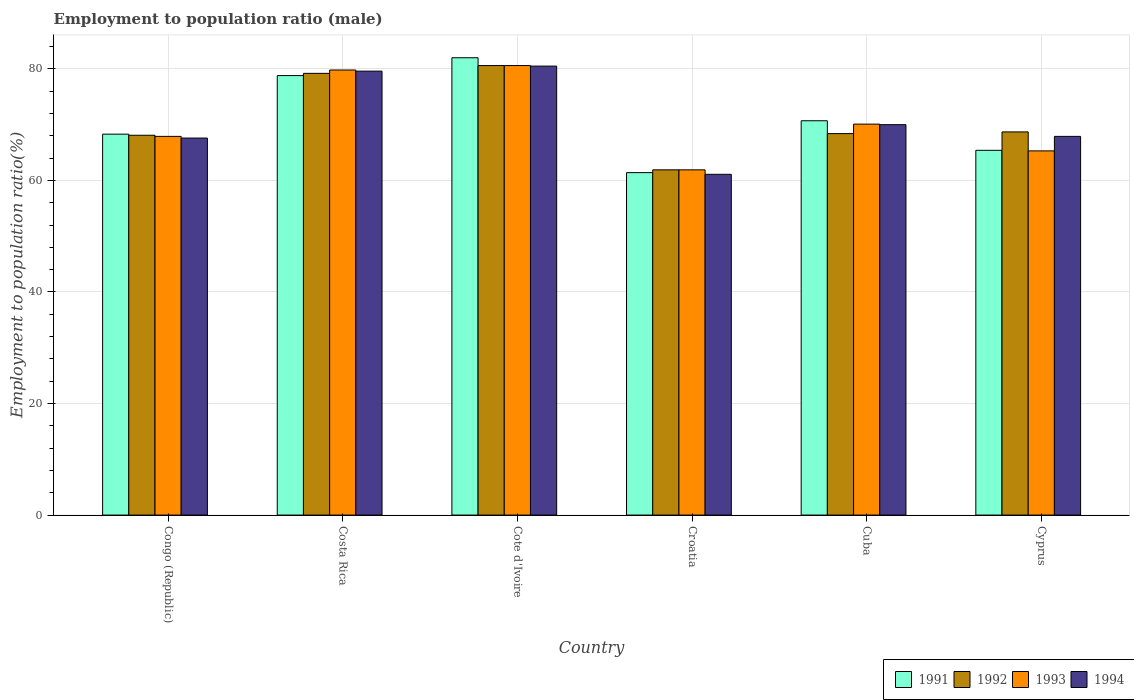How many bars are there on the 2nd tick from the right?
Give a very brief answer. 4. What is the label of the 3rd group of bars from the left?
Make the answer very short. Cote d'Ivoire. Across all countries, what is the minimum employment to population ratio in 1991?
Offer a very short reply. 61.4. In which country was the employment to population ratio in 1993 maximum?
Provide a succinct answer. Cote d'Ivoire. In which country was the employment to population ratio in 1993 minimum?
Provide a short and direct response. Croatia. What is the total employment to population ratio in 1991 in the graph?
Your response must be concise. 426.6. What is the difference between the employment to population ratio in 1994 in Cuba and that in Cyprus?
Give a very brief answer. 2.1. What is the difference between the employment to population ratio in 1994 in Cyprus and the employment to population ratio in 1992 in Cuba?
Give a very brief answer. -0.5. What is the average employment to population ratio in 1994 per country?
Ensure brevity in your answer.  71.12. What is the difference between the employment to population ratio of/in 1994 and employment to population ratio of/in 1991 in Costa Rica?
Offer a terse response. 0.8. What is the ratio of the employment to population ratio in 1991 in Costa Rica to that in Cote d'Ivoire?
Keep it short and to the point. 0.96. Is the employment to population ratio in 1992 in Congo (Republic) less than that in Cuba?
Your answer should be compact. Yes. What is the difference between the highest and the second highest employment to population ratio in 1992?
Provide a succinct answer. 11.9. What is the difference between the highest and the lowest employment to population ratio in 1992?
Offer a very short reply. 18.7. In how many countries, is the employment to population ratio in 1994 greater than the average employment to population ratio in 1994 taken over all countries?
Make the answer very short. 2. Are the values on the major ticks of Y-axis written in scientific E-notation?
Give a very brief answer. No. Does the graph contain any zero values?
Your answer should be very brief. No. Does the graph contain grids?
Provide a short and direct response. Yes. Where does the legend appear in the graph?
Provide a succinct answer. Bottom right. What is the title of the graph?
Your answer should be very brief. Employment to population ratio (male). What is the Employment to population ratio(%) in 1991 in Congo (Republic)?
Make the answer very short. 68.3. What is the Employment to population ratio(%) in 1992 in Congo (Republic)?
Give a very brief answer. 68.1. What is the Employment to population ratio(%) in 1993 in Congo (Republic)?
Your answer should be very brief. 67.9. What is the Employment to population ratio(%) of 1994 in Congo (Republic)?
Keep it short and to the point. 67.6. What is the Employment to population ratio(%) of 1991 in Costa Rica?
Offer a very short reply. 78.8. What is the Employment to population ratio(%) in 1992 in Costa Rica?
Provide a short and direct response. 79.2. What is the Employment to population ratio(%) in 1993 in Costa Rica?
Your response must be concise. 79.8. What is the Employment to population ratio(%) of 1994 in Costa Rica?
Ensure brevity in your answer.  79.6. What is the Employment to population ratio(%) in 1992 in Cote d'Ivoire?
Give a very brief answer. 80.6. What is the Employment to population ratio(%) of 1993 in Cote d'Ivoire?
Keep it short and to the point. 80.6. What is the Employment to population ratio(%) of 1994 in Cote d'Ivoire?
Provide a short and direct response. 80.5. What is the Employment to population ratio(%) in 1991 in Croatia?
Offer a very short reply. 61.4. What is the Employment to population ratio(%) in 1992 in Croatia?
Your answer should be compact. 61.9. What is the Employment to population ratio(%) in 1993 in Croatia?
Your answer should be very brief. 61.9. What is the Employment to population ratio(%) in 1994 in Croatia?
Ensure brevity in your answer.  61.1. What is the Employment to population ratio(%) in 1991 in Cuba?
Your answer should be compact. 70.7. What is the Employment to population ratio(%) of 1992 in Cuba?
Offer a terse response. 68.4. What is the Employment to population ratio(%) of 1993 in Cuba?
Offer a very short reply. 70.1. What is the Employment to population ratio(%) in 1991 in Cyprus?
Offer a very short reply. 65.4. What is the Employment to population ratio(%) in 1992 in Cyprus?
Keep it short and to the point. 68.7. What is the Employment to population ratio(%) in 1993 in Cyprus?
Make the answer very short. 65.3. What is the Employment to population ratio(%) of 1994 in Cyprus?
Your answer should be very brief. 67.9. Across all countries, what is the maximum Employment to population ratio(%) in 1992?
Provide a short and direct response. 80.6. Across all countries, what is the maximum Employment to population ratio(%) in 1993?
Make the answer very short. 80.6. Across all countries, what is the maximum Employment to population ratio(%) in 1994?
Your answer should be very brief. 80.5. Across all countries, what is the minimum Employment to population ratio(%) of 1991?
Offer a very short reply. 61.4. Across all countries, what is the minimum Employment to population ratio(%) in 1992?
Your response must be concise. 61.9. Across all countries, what is the minimum Employment to population ratio(%) in 1993?
Offer a terse response. 61.9. Across all countries, what is the minimum Employment to population ratio(%) in 1994?
Offer a terse response. 61.1. What is the total Employment to population ratio(%) in 1991 in the graph?
Give a very brief answer. 426.6. What is the total Employment to population ratio(%) in 1992 in the graph?
Your answer should be very brief. 426.9. What is the total Employment to population ratio(%) of 1993 in the graph?
Provide a succinct answer. 425.6. What is the total Employment to population ratio(%) of 1994 in the graph?
Offer a very short reply. 426.7. What is the difference between the Employment to population ratio(%) in 1991 in Congo (Republic) and that in Costa Rica?
Give a very brief answer. -10.5. What is the difference between the Employment to population ratio(%) of 1993 in Congo (Republic) and that in Costa Rica?
Make the answer very short. -11.9. What is the difference between the Employment to population ratio(%) in 1991 in Congo (Republic) and that in Cote d'Ivoire?
Give a very brief answer. -13.7. What is the difference between the Employment to population ratio(%) in 1992 in Congo (Republic) and that in Cote d'Ivoire?
Your response must be concise. -12.5. What is the difference between the Employment to population ratio(%) of 1993 in Congo (Republic) and that in Cote d'Ivoire?
Make the answer very short. -12.7. What is the difference between the Employment to population ratio(%) in 1994 in Congo (Republic) and that in Cote d'Ivoire?
Give a very brief answer. -12.9. What is the difference between the Employment to population ratio(%) in 1991 in Congo (Republic) and that in Croatia?
Your response must be concise. 6.9. What is the difference between the Employment to population ratio(%) in 1992 in Congo (Republic) and that in Croatia?
Provide a short and direct response. 6.2. What is the difference between the Employment to population ratio(%) in 1994 in Congo (Republic) and that in Croatia?
Give a very brief answer. 6.5. What is the difference between the Employment to population ratio(%) of 1991 in Congo (Republic) and that in Cuba?
Offer a terse response. -2.4. What is the difference between the Employment to population ratio(%) of 1992 in Congo (Republic) and that in Cuba?
Your answer should be very brief. -0.3. What is the difference between the Employment to population ratio(%) in 1994 in Congo (Republic) and that in Cuba?
Your response must be concise. -2.4. What is the difference between the Employment to population ratio(%) in 1993 in Congo (Republic) and that in Cyprus?
Provide a short and direct response. 2.6. What is the difference between the Employment to population ratio(%) of 1993 in Costa Rica and that in Cote d'Ivoire?
Offer a very short reply. -0.8. What is the difference between the Employment to population ratio(%) of 1994 in Costa Rica and that in Cote d'Ivoire?
Ensure brevity in your answer.  -0.9. What is the difference between the Employment to population ratio(%) of 1992 in Costa Rica and that in Croatia?
Your answer should be compact. 17.3. What is the difference between the Employment to population ratio(%) in 1991 in Costa Rica and that in Cuba?
Provide a short and direct response. 8.1. What is the difference between the Employment to population ratio(%) of 1992 in Costa Rica and that in Cuba?
Your answer should be compact. 10.8. What is the difference between the Employment to population ratio(%) in 1993 in Costa Rica and that in Cuba?
Your response must be concise. 9.7. What is the difference between the Employment to population ratio(%) in 1992 in Costa Rica and that in Cyprus?
Give a very brief answer. 10.5. What is the difference between the Employment to population ratio(%) of 1994 in Costa Rica and that in Cyprus?
Give a very brief answer. 11.7. What is the difference between the Employment to population ratio(%) in 1991 in Cote d'Ivoire and that in Croatia?
Offer a terse response. 20.6. What is the difference between the Employment to population ratio(%) in 1992 in Cote d'Ivoire and that in Croatia?
Provide a short and direct response. 18.7. What is the difference between the Employment to population ratio(%) of 1994 in Cote d'Ivoire and that in Croatia?
Make the answer very short. 19.4. What is the difference between the Employment to population ratio(%) in 1994 in Cote d'Ivoire and that in Cuba?
Provide a succinct answer. 10.5. What is the difference between the Employment to population ratio(%) in 1992 in Cote d'Ivoire and that in Cyprus?
Your answer should be compact. 11.9. What is the difference between the Employment to population ratio(%) in 1992 in Croatia and that in Cuba?
Your answer should be compact. -6.5. What is the difference between the Employment to population ratio(%) in 1993 in Croatia and that in Cyprus?
Your answer should be very brief. -3.4. What is the difference between the Employment to population ratio(%) of 1994 in Croatia and that in Cyprus?
Your answer should be very brief. -6.8. What is the difference between the Employment to population ratio(%) of 1991 in Congo (Republic) and the Employment to population ratio(%) of 1993 in Costa Rica?
Your answer should be compact. -11.5. What is the difference between the Employment to population ratio(%) of 1992 in Congo (Republic) and the Employment to population ratio(%) of 1993 in Costa Rica?
Your response must be concise. -11.7. What is the difference between the Employment to population ratio(%) in 1991 in Congo (Republic) and the Employment to population ratio(%) in 1992 in Cote d'Ivoire?
Provide a succinct answer. -12.3. What is the difference between the Employment to population ratio(%) in 1991 in Congo (Republic) and the Employment to population ratio(%) in 1993 in Cote d'Ivoire?
Make the answer very short. -12.3. What is the difference between the Employment to population ratio(%) of 1991 in Congo (Republic) and the Employment to population ratio(%) of 1994 in Cote d'Ivoire?
Keep it short and to the point. -12.2. What is the difference between the Employment to population ratio(%) of 1992 in Congo (Republic) and the Employment to population ratio(%) of 1993 in Cote d'Ivoire?
Provide a succinct answer. -12.5. What is the difference between the Employment to population ratio(%) in 1992 in Congo (Republic) and the Employment to population ratio(%) in 1994 in Cote d'Ivoire?
Offer a very short reply. -12.4. What is the difference between the Employment to population ratio(%) in 1991 in Congo (Republic) and the Employment to population ratio(%) in 1993 in Croatia?
Your response must be concise. 6.4. What is the difference between the Employment to population ratio(%) in 1991 in Congo (Republic) and the Employment to population ratio(%) in 1994 in Croatia?
Offer a very short reply. 7.2. What is the difference between the Employment to population ratio(%) of 1992 in Congo (Republic) and the Employment to population ratio(%) of 1994 in Croatia?
Your answer should be compact. 7. What is the difference between the Employment to population ratio(%) of 1993 in Congo (Republic) and the Employment to population ratio(%) of 1994 in Croatia?
Keep it short and to the point. 6.8. What is the difference between the Employment to population ratio(%) in 1991 in Congo (Republic) and the Employment to population ratio(%) in 1992 in Cuba?
Keep it short and to the point. -0.1. What is the difference between the Employment to population ratio(%) in 1991 in Congo (Republic) and the Employment to population ratio(%) in 1994 in Cuba?
Give a very brief answer. -1.7. What is the difference between the Employment to population ratio(%) in 1992 in Congo (Republic) and the Employment to population ratio(%) in 1993 in Cuba?
Your response must be concise. -2. What is the difference between the Employment to population ratio(%) in 1992 in Congo (Republic) and the Employment to population ratio(%) in 1994 in Cuba?
Your answer should be compact. -1.9. What is the difference between the Employment to population ratio(%) of 1991 in Congo (Republic) and the Employment to population ratio(%) of 1994 in Cyprus?
Your answer should be very brief. 0.4. What is the difference between the Employment to population ratio(%) of 1992 in Congo (Republic) and the Employment to population ratio(%) of 1993 in Cyprus?
Your answer should be very brief. 2.8. What is the difference between the Employment to population ratio(%) in 1991 in Costa Rica and the Employment to population ratio(%) in 1993 in Cote d'Ivoire?
Your answer should be compact. -1.8. What is the difference between the Employment to population ratio(%) in 1992 in Costa Rica and the Employment to population ratio(%) in 1994 in Cote d'Ivoire?
Your answer should be compact. -1.3. What is the difference between the Employment to population ratio(%) in 1991 in Costa Rica and the Employment to population ratio(%) in 1992 in Croatia?
Offer a terse response. 16.9. What is the difference between the Employment to population ratio(%) of 1991 in Costa Rica and the Employment to population ratio(%) of 1993 in Croatia?
Your response must be concise. 16.9. What is the difference between the Employment to population ratio(%) in 1992 in Costa Rica and the Employment to population ratio(%) in 1993 in Croatia?
Provide a short and direct response. 17.3. What is the difference between the Employment to population ratio(%) in 1992 in Costa Rica and the Employment to population ratio(%) in 1994 in Croatia?
Your response must be concise. 18.1. What is the difference between the Employment to population ratio(%) of 1993 in Costa Rica and the Employment to population ratio(%) of 1994 in Croatia?
Your answer should be very brief. 18.7. What is the difference between the Employment to population ratio(%) in 1992 in Costa Rica and the Employment to population ratio(%) in 1994 in Cuba?
Give a very brief answer. 9.2. What is the difference between the Employment to population ratio(%) in 1992 in Costa Rica and the Employment to population ratio(%) in 1993 in Cyprus?
Offer a very short reply. 13.9. What is the difference between the Employment to population ratio(%) in 1992 in Costa Rica and the Employment to population ratio(%) in 1994 in Cyprus?
Make the answer very short. 11.3. What is the difference between the Employment to population ratio(%) of 1991 in Cote d'Ivoire and the Employment to population ratio(%) of 1992 in Croatia?
Ensure brevity in your answer.  20.1. What is the difference between the Employment to population ratio(%) of 1991 in Cote d'Ivoire and the Employment to population ratio(%) of 1993 in Croatia?
Your response must be concise. 20.1. What is the difference between the Employment to population ratio(%) in 1991 in Cote d'Ivoire and the Employment to population ratio(%) in 1994 in Croatia?
Make the answer very short. 20.9. What is the difference between the Employment to population ratio(%) of 1991 in Cote d'Ivoire and the Employment to population ratio(%) of 1992 in Cuba?
Ensure brevity in your answer.  13.6. What is the difference between the Employment to population ratio(%) in 1993 in Cote d'Ivoire and the Employment to population ratio(%) in 1994 in Cuba?
Your response must be concise. 10.6. What is the difference between the Employment to population ratio(%) of 1991 in Cote d'Ivoire and the Employment to population ratio(%) of 1992 in Cyprus?
Provide a short and direct response. 13.3. What is the difference between the Employment to population ratio(%) in 1991 in Cote d'Ivoire and the Employment to population ratio(%) in 1994 in Cyprus?
Provide a short and direct response. 14.1. What is the difference between the Employment to population ratio(%) of 1992 in Cote d'Ivoire and the Employment to population ratio(%) of 1994 in Cyprus?
Your answer should be compact. 12.7. What is the difference between the Employment to population ratio(%) in 1993 in Cote d'Ivoire and the Employment to population ratio(%) in 1994 in Cyprus?
Provide a succinct answer. 12.7. What is the difference between the Employment to population ratio(%) of 1992 in Croatia and the Employment to population ratio(%) of 1994 in Cuba?
Provide a succinct answer. -8.1. What is the difference between the Employment to population ratio(%) of 1992 in Croatia and the Employment to population ratio(%) of 1994 in Cyprus?
Offer a very short reply. -6. What is the difference between the Employment to population ratio(%) in 1993 in Croatia and the Employment to population ratio(%) in 1994 in Cyprus?
Your answer should be very brief. -6. What is the difference between the Employment to population ratio(%) of 1992 in Cuba and the Employment to population ratio(%) of 1993 in Cyprus?
Your response must be concise. 3.1. What is the difference between the Employment to population ratio(%) in 1992 in Cuba and the Employment to population ratio(%) in 1994 in Cyprus?
Offer a very short reply. 0.5. What is the difference between the Employment to population ratio(%) of 1993 in Cuba and the Employment to population ratio(%) of 1994 in Cyprus?
Offer a very short reply. 2.2. What is the average Employment to population ratio(%) in 1991 per country?
Ensure brevity in your answer.  71.1. What is the average Employment to population ratio(%) of 1992 per country?
Keep it short and to the point. 71.15. What is the average Employment to population ratio(%) of 1993 per country?
Make the answer very short. 70.93. What is the average Employment to population ratio(%) of 1994 per country?
Offer a terse response. 71.12. What is the difference between the Employment to population ratio(%) of 1991 and Employment to population ratio(%) of 1993 in Congo (Republic)?
Ensure brevity in your answer.  0.4. What is the difference between the Employment to population ratio(%) in 1991 and Employment to population ratio(%) in 1994 in Congo (Republic)?
Offer a very short reply. 0.7. What is the difference between the Employment to population ratio(%) of 1992 and Employment to population ratio(%) of 1993 in Congo (Republic)?
Provide a succinct answer. 0.2. What is the difference between the Employment to population ratio(%) in 1991 and Employment to population ratio(%) in 1992 in Costa Rica?
Your response must be concise. -0.4. What is the difference between the Employment to population ratio(%) in 1991 and Employment to population ratio(%) in 1993 in Costa Rica?
Keep it short and to the point. -1. What is the difference between the Employment to population ratio(%) in 1992 and Employment to population ratio(%) in 1993 in Costa Rica?
Provide a short and direct response. -0.6. What is the difference between the Employment to population ratio(%) in 1992 and Employment to population ratio(%) in 1994 in Costa Rica?
Offer a terse response. -0.4. What is the difference between the Employment to population ratio(%) of 1993 and Employment to population ratio(%) of 1994 in Costa Rica?
Your answer should be very brief. 0.2. What is the difference between the Employment to population ratio(%) of 1991 and Employment to population ratio(%) of 1993 in Cote d'Ivoire?
Make the answer very short. 1.4. What is the difference between the Employment to population ratio(%) of 1992 and Employment to population ratio(%) of 1993 in Cote d'Ivoire?
Provide a short and direct response. 0. What is the difference between the Employment to population ratio(%) of 1993 and Employment to population ratio(%) of 1994 in Cote d'Ivoire?
Your answer should be very brief. 0.1. What is the difference between the Employment to population ratio(%) in 1991 and Employment to population ratio(%) in 1993 in Croatia?
Give a very brief answer. -0.5. What is the difference between the Employment to population ratio(%) of 1991 and Employment to population ratio(%) of 1994 in Croatia?
Provide a succinct answer. 0.3. What is the difference between the Employment to population ratio(%) in 1993 and Employment to population ratio(%) in 1994 in Croatia?
Your answer should be very brief. 0.8. What is the difference between the Employment to population ratio(%) of 1991 and Employment to population ratio(%) of 1992 in Cyprus?
Ensure brevity in your answer.  -3.3. What is the difference between the Employment to population ratio(%) in 1992 and Employment to population ratio(%) in 1994 in Cyprus?
Give a very brief answer. 0.8. What is the difference between the Employment to population ratio(%) of 1993 and Employment to population ratio(%) of 1994 in Cyprus?
Offer a terse response. -2.6. What is the ratio of the Employment to population ratio(%) of 1991 in Congo (Republic) to that in Costa Rica?
Your answer should be compact. 0.87. What is the ratio of the Employment to population ratio(%) of 1992 in Congo (Republic) to that in Costa Rica?
Your response must be concise. 0.86. What is the ratio of the Employment to population ratio(%) of 1993 in Congo (Republic) to that in Costa Rica?
Keep it short and to the point. 0.85. What is the ratio of the Employment to population ratio(%) of 1994 in Congo (Republic) to that in Costa Rica?
Offer a terse response. 0.85. What is the ratio of the Employment to population ratio(%) in 1991 in Congo (Republic) to that in Cote d'Ivoire?
Your answer should be very brief. 0.83. What is the ratio of the Employment to population ratio(%) in 1992 in Congo (Republic) to that in Cote d'Ivoire?
Make the answer very short. 0.84. What is the ratio of the Employment to population ratio(%) of 1993 in Congo (Republic) to that in Cote d'Ivoire?
Keep it short and to the point. 0.84. What is the ratio of the Employment to population ratio(%) of 1994 in Congo (Republic) to that in Cote d'Ivoire?
Provide a succinct answer. 0.84. What is the ratio of the Employment to population ratio(%) of 1991 in Congo (Republic) to that in Croatia?
Make the answer very short. 1.11. What is the ratio of the Employment to population ratio(%) of 1992 in Congo (Republic) to that in Croatia?
Your response must be concise. 1.1. What is the ratio of the Employment to population ratio(%) in 1993 in Congo (Republic) to that in Croatia?
Make the answer very short. 1.1. What is the ratio of the Employment to population ratio(%) of 1994 in Congo (Republic) to that in Croatia?
Your answer should be compact. 1.11. What is the ratio of the Employment to population ratio(%) of 1991 in Congo (Republic) to that in Cuba?
Offer a terse response. 0.97. What is the ratio of the Employment to population ratio(%) of 1992 in Congo (Republic) to that in Cuba?
Your response must be concise. 1. What is the ratio of the Employment to population ratio(%) in 1993 in Congo (Republic) to that in Cuba?
Your answer should be very brief. 0.97. What is the ratio of the Employment to population ratio(%) in 1994 in Congo (Republic) to that in Cuba?
Make the answer very short. 0.97. What is the ratio of the Employment to population ratio(%) of 1991 in Congo (Republic) to that in Cyprus?
Your answer should be very brief. 1.04. What is the ratio of the Employment to population ratio(%) of 1992 in Congo (Republic) to that in Cyprus?
Ensure brevity in your answer.  0.99. What is the ratio of the Employment to population ratio(%) in 1993 in Congo (Republic) to that in Cyprus?
Make the answer very short. 1.04. What is the ratio of the Employment to population ratio(%) in 1992 in Costa Rica to that in Cote d'Ivoire?
Keep it short and to the point. 0.98. What is the ratio of the Employment to population ratio(%) of 1993 in Costa Rica to that in Cote d'Ivoire?
Provide a short and direct response. 0.99. What is the ratio of the Employment to population ratio(%) of 1994 in Costa Rica to that in Cote d'Ivoire?
Provide a succinct answer. 0.99. What is the ratio of the Employment to population ratio(%) of 1991 in Costa Rica to that in Croatia?
Offer a very short reply. 1.28. What is the ratio of the Employment to population ratio(%) in 1992 in Costa Rica to that in Croatia?
Make the answer very short. 1.28. What is the ratio of the Employment to population ratio(%) of 1993 in Costa Rica to that in Croatia?
Your answer should be compact. 1.29. What is the ratio of the Employment to population ratio(%) of 1994 in Costa Rica to that in Croatia?
Your answer should be compact. 1.3. What is the ratio of the Employment to population ratio(%) of 1991 in Costa Rica to that in Cuba?
Keep it short and to the point. 1.11. What is the ratio of the Employment to population ratio(%) of 1992 in Costa Rica to that in Cuba?
Ensure brevity in your answer.  1.16. What is the ratio of the Employment to population ratio(%) in 1993 in Costa Rica to that in Cuba?
Give a very brief answer. 1.14. What is the ratio of the Employment to population ratio(%) of 1994 in Costa Rica to that in Cuba?
Provide a short and direct response. 1.14. What is the ratio of the Employment to population ratio(%) of 1991 in Costa Rica to that in Cyprus?
Keep it short and to the point. 1.2. What is the ratio of the Employment to population ratio(%) in 1992 in Costa Rica to that in Cyprus?
Offer a terse response. 1.15. What is the ratio of the Employment to population ratio(%) in 1993 in Costa Rica to that in Cyprus?
Make the answer very short. 1.22. What is the ratio of the Employment to population ratio(%) of 1994 in Costa Rica to that in Cyprus?
Offer a terse response. 1.17. What is the ratio of the Employment to population ratio(%) in 1991 in Cote d'Ivoire to that in Croatia?
Your answer should be very brief. 1.34. What is the ratio of the Employment to population ratio(%) in 1992 in Cote d'Ivoire to that in Croatia?
Give a very brief answer. 1.3. What is the ratio of the Employment to population ratio(%) of 1993 in Cote d'Ivoire to that in Croatia?
Your answer should be compact. 1.3. What is the ratio of the Employment to population ratio(%) of 1994 in Cote d'Ivoire to that in Croatia?
Provide a short and direct response. 1.32. What is the ratio of the Employment to population ratio(%) of 1991 in Cote d'Ivoire to that in Cuba?
Ensure brevity in your answer.  1.16. What is the ratio of the Employment to population ratio(%) in 1992 in Cote d'Ivoire to that in Cuba?
Make the answer very short. 1.18. What is the ratio of the Employment to population ratio(%) in 1993 in Cote d'Ivoire to that in Cuba?
Make the answer very short. 1.15. What is the ratio of the Employment to population ratio(%) in 1994 in Cote d'Ivoire to that in Cuba?
Make the answer very short. 1.15. What is the ratio of the Employment to population ratio(%) of 1991 in Cote d'Ivoire to that in Cyprus?
Keep it short and to the point. 1.25. What is the ratio of the Employment to population ratio(%) in 1992 in Cote d'Ivoire to that in Cyprus?
Ensure brevity in your answer.  1.17. What is the ratio of the Employment to population ratio(%) of 1993 in Cote d'Ivoire to that in Cyprus?
Your answer should be compact. 1.23. What is the ratio of the Employment to population ratio(%) of 1994 in Cote d'Ivoire to that in Cyprus?
Give a very brief answer. 1.19. What is the ratio of the Employment to population ratio(%) in 1991 in Croatia to that in Cuba?
Your answer should be compact. 0.87. What is the ratio of the Employment to population ratio(%) of 1992 in Croatia to that in Cuba?
Give a very brief answer. 0.91. What is the ratio of the Employment to population ratio(%) of 1993 in Croatia to that in Cuba?
Your answer should be very brief. 0.88. What is the ratio of the Employment to population ratio(%) in 1994 in Croatia to that in Cuba?
Your answer should be compact. 0.87. What is the ratio of the Employment to population ratio(%) in 1991 in Croatia to that in Cyprus?
Offer a terse response. 0.94. What is the ratio of the Employment to population ratio(%) of 1992 in Croatia to that in Cyprus?
Your answer should be compact. 0.9. What is the ratio of the Employment to population ratio(%) of 1993 in Croatia to that in Cyprus?
Provide a succinct answer. 0.95. What is the ratio of the Employment to population ratio(%) in 1994 in Croatia to that in Cyprus?
Keep it short and to the point. 0.9. What is the ratio of the Employment to population ratio(%) of 1991 in Cuba to that in Cyprus?
Provide a succinct answer. 1.08. What is the ratio of the Employment to population ratio(%) of 1993 in Cuba to that in Cyprus?
Make the answer very short. 1.07. What is the ratio of the Employment to population ratio(%) of 1994 in Cuba to that in Cyprus?
Provide a succinct answer. 1.03. What is the difference between the highest and the second highest Employment to population ratio(%) in 1991?
Provide a succinct answer. 3.2. What is the difference between the highest and the second highest Employment to population ratio(%) of 1994?
Make the answer very short. 0.9. What is the difference between the highest and the lowest Employment to population ratio(%) in 1991?
Provide a succinct answer. 20.6. 